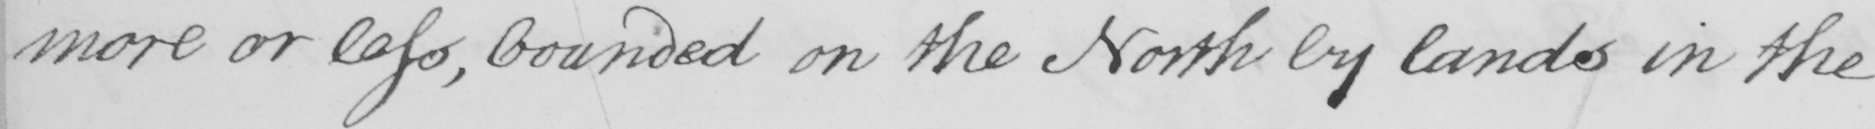What does this handwritten line say? more or less , bounded on the North by lands in the 